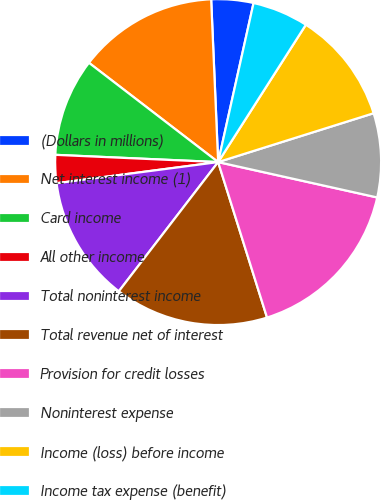<chart> <loc_0><loc_0><loc_500><loc_500><pie_chart><fcel>(Dollars in millions)<fcel>Net interest income (1)<fcel>Card income<fcel>All other income<fcel>Total noninterest income<fcel>Total revenue net of interest<fcel>Provision for credit losses<fcel>Noninterest expense<fcel>Income (loss) before income<fcel>Income tax expense (benefit)<nl><fcel>4.17%<fcel>13.89%<fcel>9.72%<fcel>2.78%<fcel>12.5%<fcel>15.28%<fcel>16.67%<fcel>8.33%<fcel>11.11%<fcel>5.56%<nl></chart> 